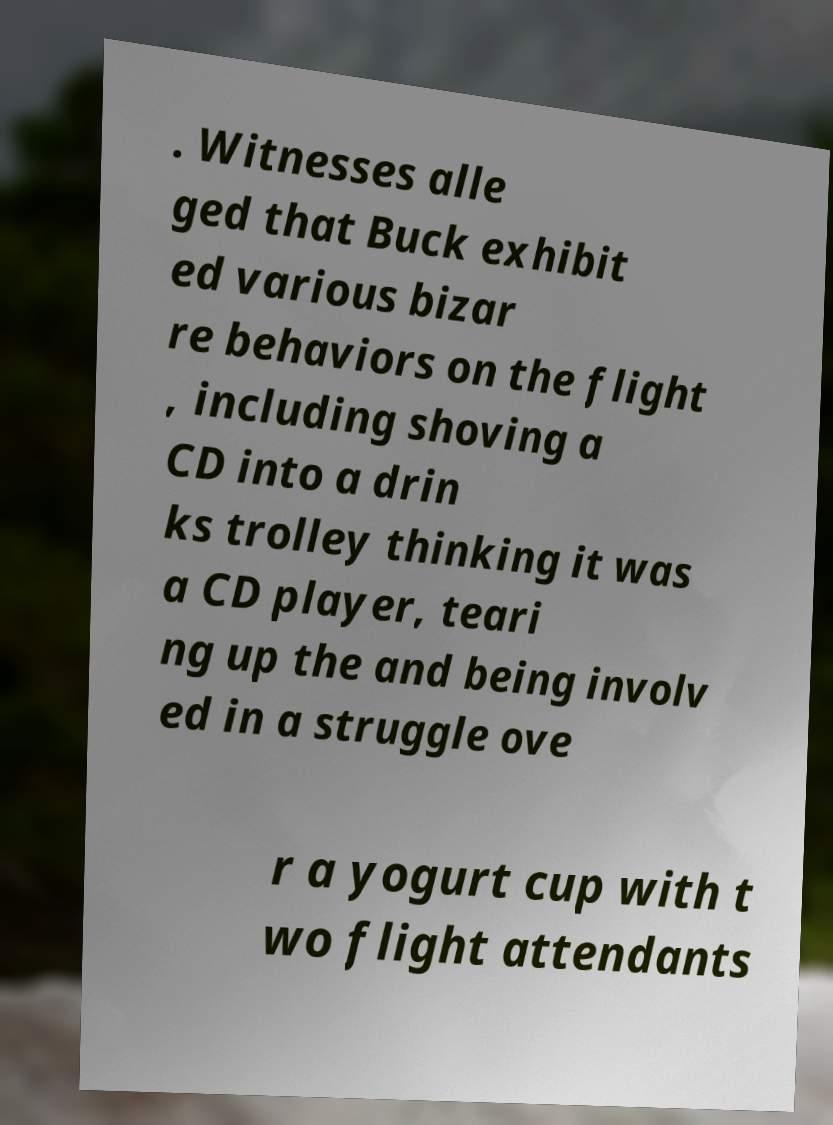Can you accurately transcribe the text from the provided image for me? . Witnesses alle ged that Buck exhibit ed various bizar re behaviors on the flight , including shoving a CD into a drin ks trolley thinking it was a CD player, teari ng up the and being involv ed in a struggle ove r a yogurt cup with t wo flight attendants 